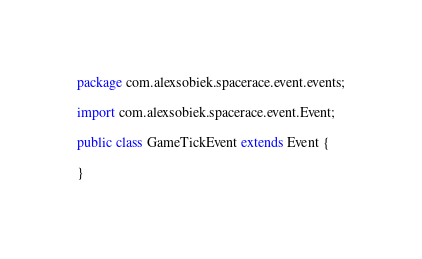Convert code to text. <code><loc_0><loc_0><loc_500><loc_500><_Java_>package com.alexsobiek.spacerace.event.events;

import com.alexsobiek.spacerace.event.Event;

public class GameTickEvent extends Event {

}
</code> 